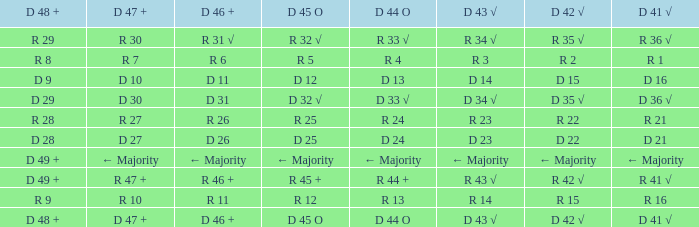What is the value of D 46 +, when the value of D 42 √ is r 2? R 6. 